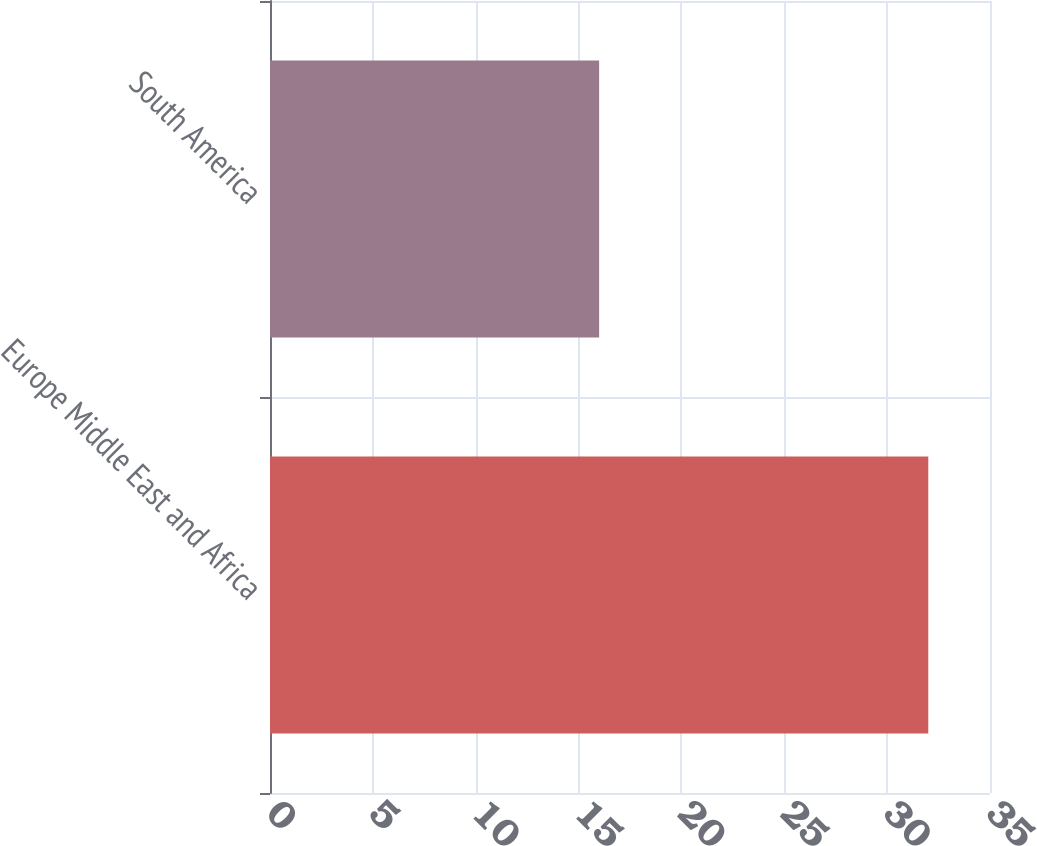<chart> <loc_0><loc_0><loc_500><loc_500><bar_chart><fcel>Europe Middle East and Africa<fcel>South America<nl><fcel>32<fcel>16<nl></chart> 